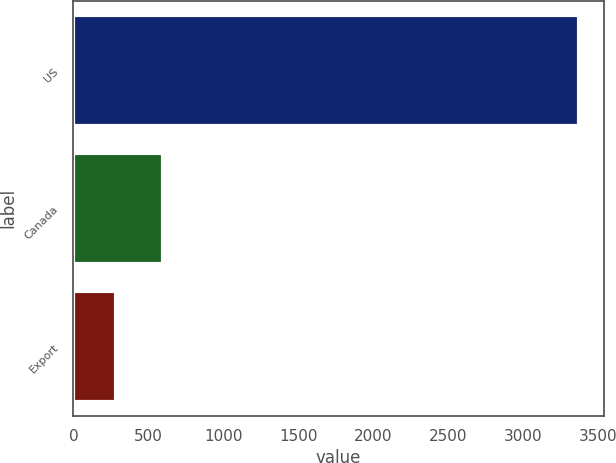Convert chart. <chart><loc_0><loc_0><loc_500><loc_500><bar_chart><fcel>US<fcel>Canada<fcel>Export<nl><fcel>3368.3<fcel>595.22<fcel>287.1<nl></chart> 